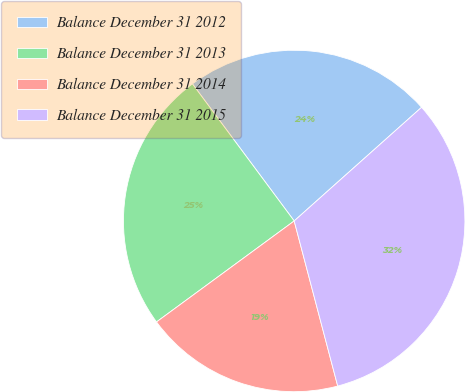Convert chart to OTSL. <chart><loc_0><loc_0><loc_500><loc_500><pie_chart><fcel>Balance December 31 2012<fcel>Balance December 31 2013<fcel>Balance December 31 2014<fcel>Balance December 31 2015<nl><fcel>23.57%<fcel>24.91%<fcel>19.03%<fcel>32.49%<nl></chart> 